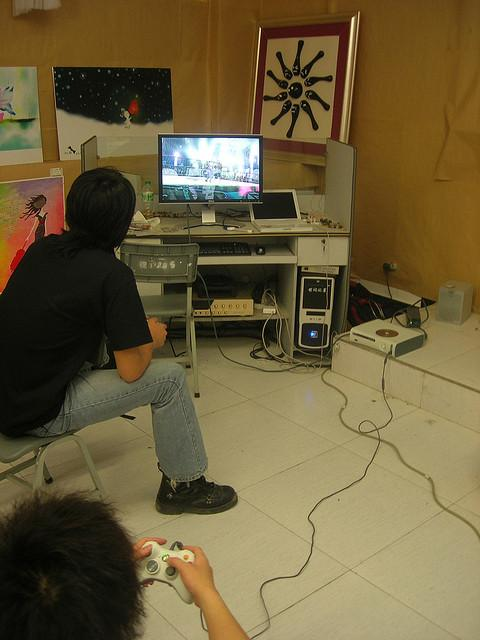What are the people playing?

Choices:
A) basketball
B) tennis
C) video games
D) baseball video games 